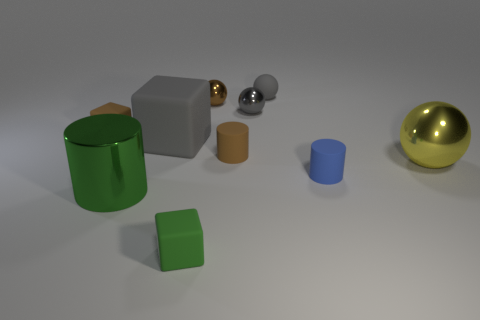Is the tiny brown metal thing the same shape as the big green metal thing?
Keep it short and to the point. No. What color is the cylinder that is the same size as the yellow metallic ball?
Your answer should be compact. Green. Is the number of tiny brown matte things right of the small green matte object less than the number of small brown objects to the right of the large green object?
Your answer should be very brief. Yes. The tiny matte object in front of the rubber cylinder in front of the big metallic ball that is in front of the small brown shiny object is what shape?
Your answer should be compact. Cube. There is a shiny sphere that is left of the small gray shiny object; does it have the same color as the tiny cube behind the small blue cylinder?
Your answer should be very brief. Yes. There is a object that is the same color as the shiny cylinder; what is its shape?
Ensure brevity in your answer.  Cube. What number of metal objects are either blue objects or yellow things?
Your response must be concise. 1. There is a tiny rubber block that is on the right side of the large thing in front of the yellow shiny ball behind the small green object; what is its color?
Offer a terse response. Green. There is another matte object that is the same shape as the large yellow thing; what is its color?
Make the answer very short. Gray. Are there any other things that have the same color as the big cube?
Ensure brevity in your answer.  Yes. 